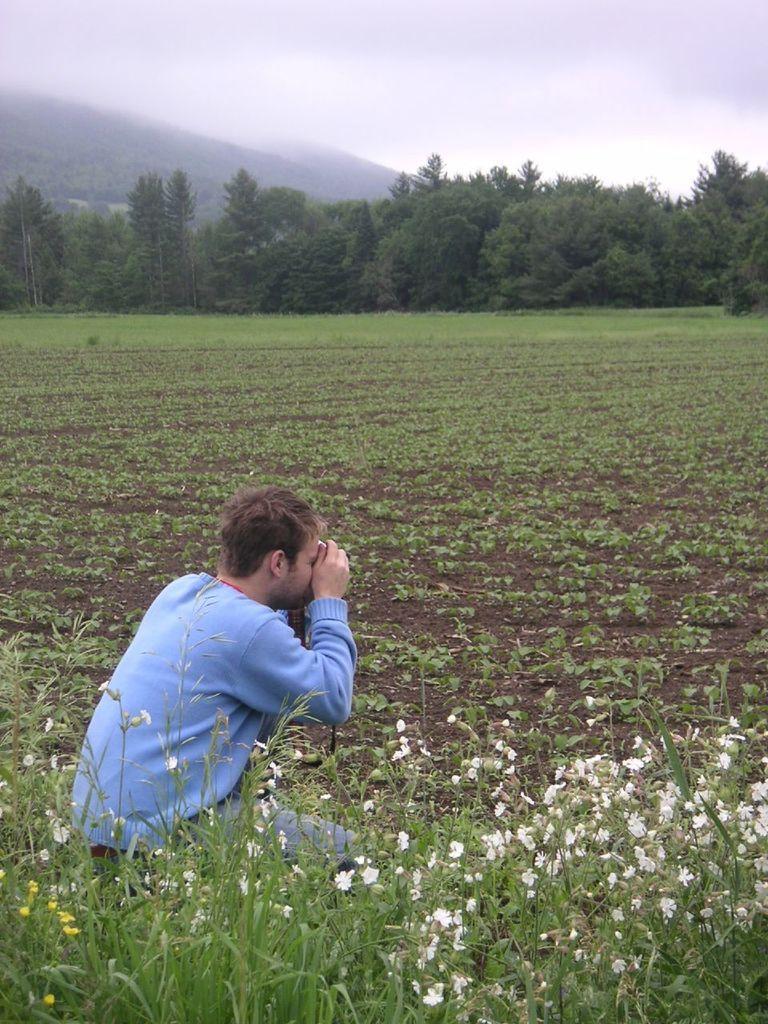In one or two sentences, can you explain what this image depicts? At the bottom of this image, there are plants having flowers. Behind them, there is a person squatting on the ground. In the background, there are plants, trees and there are clouds in the sky. 